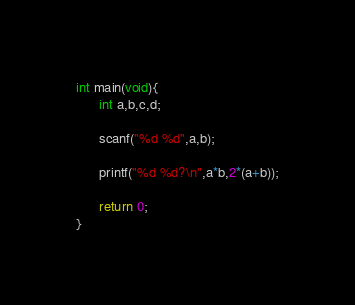<code> <loc_0><loc_0><loc_500><loc_500><_C_>int main(void){
      int a,b,c,d;

      scanf("%d %d",a,b);

      printf("%d %d?\n",a*b,2*(a+b));

      return 0;
}</code> 